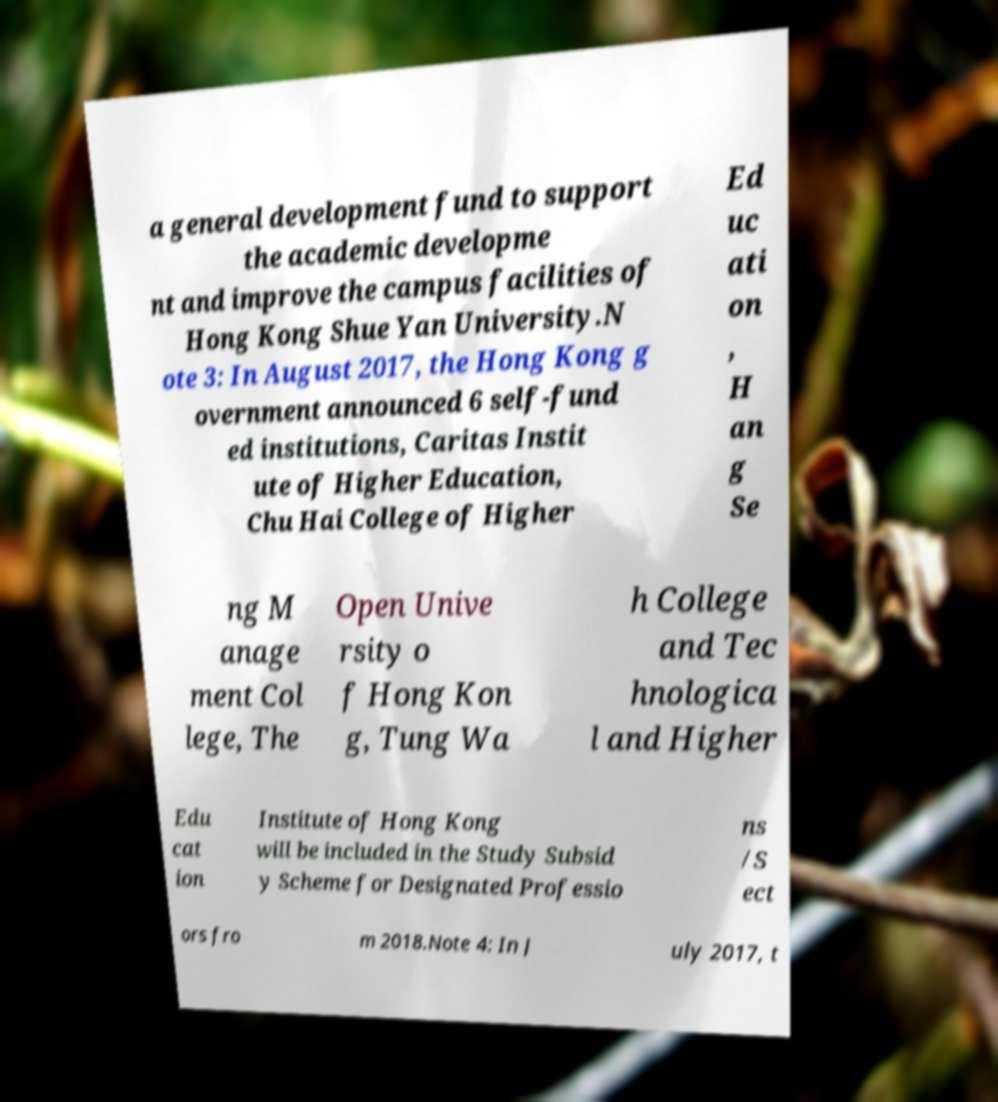I need the written content from this picture converted into text. Can you do that? a general development fund to support the academic developme nt and improve the campus facilities of Hong Kong Shue Yan University.N ote 3: In August 2017, the Hong Kong g overnment announced 6 self-fund ed institutions, Caritas Instit ute of Higher Education, Chu Hai College of Higher Ed uc ati on , H an g Se ng M anage ment Col lege, The Open Unive rsity o f Hong Kon g, Tung Wa h College and Tec hnologica l and Higher Edu cat ion Institute of Hong Kong will be included in the Study Subsid y Scheme for Designated Professio ns /S ect ors fro m 2018.Note 4: In J uly 2017, t 